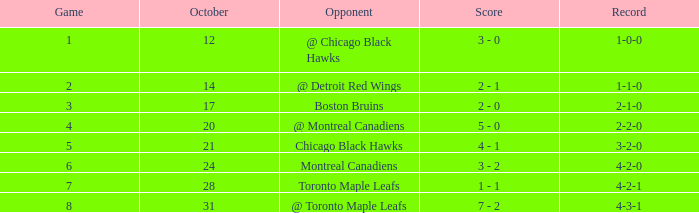Could you help me parse every detail presented in this table? {'header': ['Game', 'October', 'Opponent', 'Score', 'Record'], 'rows': [['1', '12', '@ Chicago Black Hawks', '3 - 0', '1-0-0'], ['2', '14', '@ Detroit Red Wings', '2 - 1', '1-1-0'], ['3', '17', 'Boston Bruins', '2 - 0', '2-1-0'], ['4', '20', '@ Montreal Canadiens', '5 - 0', '2-2-0'], ['5', '21', 'Chicago Black Hawks', '4 - 1', '3-2-0'], ['6', '24', 'Montreal Canadiens', '3 - 2', '4-2-0'], ['7', '28', 'Toronto Maple Leafs', '1 - 1', '4-2-1'], ['8', '31', '@ Toronto Maple Leafs', '7 - 2', '4-3-1']]} What was the score of the game after game 6 on October 28? 1 - 1. 